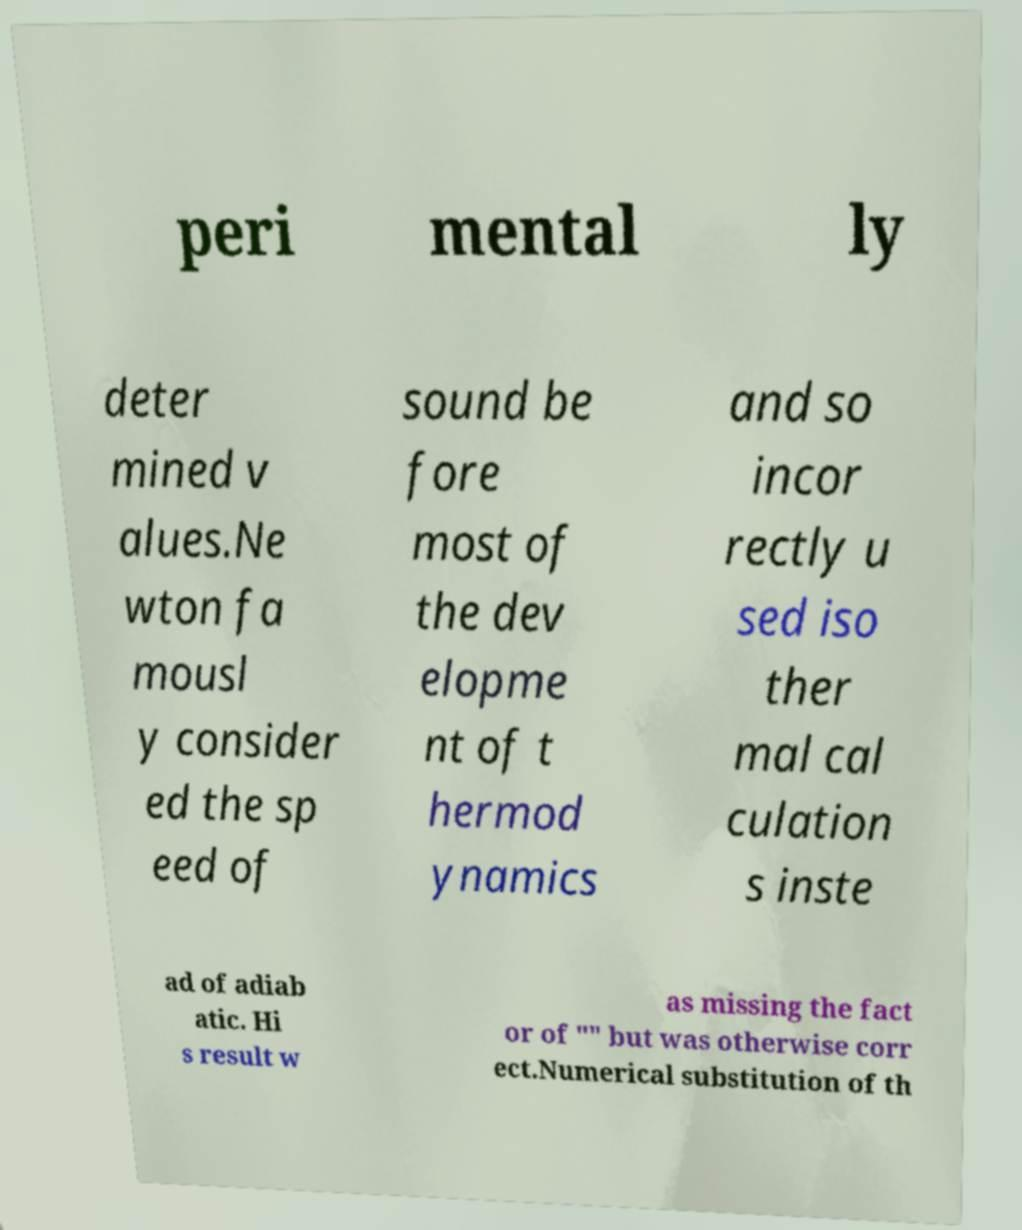Can you accurately transcribe the text from the provided image for me? peri mental ly deter mined v alues.Ne wton fa mousl y consider ed the sp eed of sound be fore most of the dev elopme nt of t hermod ynamics and so incor rectly u sed iso ther mal cal culation s inste ad of adiab atic. Hi s result w as missing the fact or of "" but was otherwise corr ect.Numerical substitution of th 